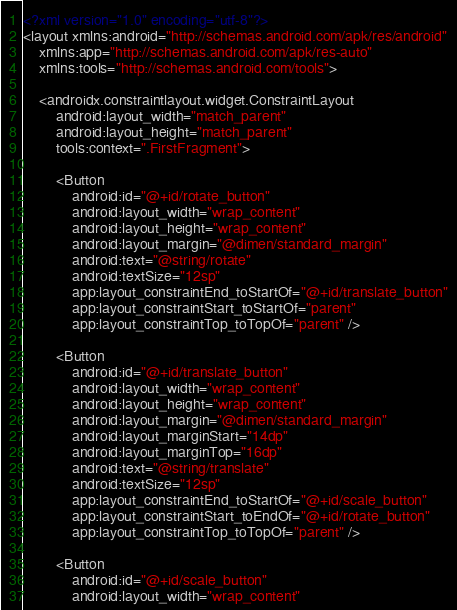Convert code to text. <code><loc_0><loc_0><loc_500><loc_500><_XML_><?xml version="1.0" encoding="utf-8"?>
<layout xmlns:android="http://schemas.android.com/apk/res/android"
    xmlns:app="http://schemas.android.com/apk/res-auto"
    xmlns:tools="http://schemas.android.com/tools">

    <androidx.constraintlayout.widget.ConstraintLayout
        android:layout_width="match_parent"
        android:layout_height="match_parent"
        tools:context=".FirstFragment">

        <Button
            android:id="@+id/rotate_button"
            android:layout_width="wrap_content"
            android:layout_height="wrap_content"
            android:layout_margin="@dimen/standard_margin"
            android:text="@string/rotate"
            android:textSize="12sp"
            app:layout_constraintEnd_toStartOf="@+id/translate_button"
            app:layout_constraintStart_toStartOf="parent"
            app:layout_constraintTop_toTopOf="parent" />

        <Button
            android:id="@+id/translate_button"
            android:layout_width="wrap_content"
            android:layout_height="wrap_content"
            android:layout_margin="@dimen/standard_margin"
            android:layout_marginStart="14dp"
            android:layout_marginTop="16dp"
            android:text="@string/translate"
            android:textSize="12sp"
            app:layout_constraintEnd_toStartOf="@+id/scale_button"
            app:layout_constraintStart_toEndOf="@+id/rotate_button"
            app:layout_constraintTop_toTopOf="parent" />

        <Button
            android:id="@+id/scale_button"
            android:layout_width="wrap_content"</code> 